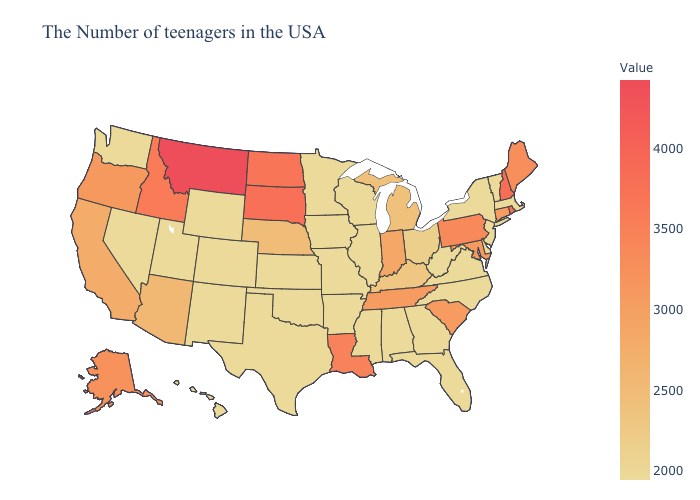Among the states that border Louisiana , which have the highest value?
Keep it brief. Mississippi, Arkansas, Texas. Does the map have missing data?
Write a very short answer. No. Among the states that border California , which have the highest value?
Be succinct. Oregon. Which states have the lowest value in the West?
Answer briefly. Wyoming, Colorado, New Mexico, Utah, Nevada, Washington, Hawaii. Among the states that border Virginia , which have the highest value?
Short answer required. Maryland. 